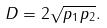Convert formula to latex. <formula><loc_0><loc_0><loc_500><loc_500>D = 2 \sqrt { p _ { 1 } p _ { 2 } } .</formula> 